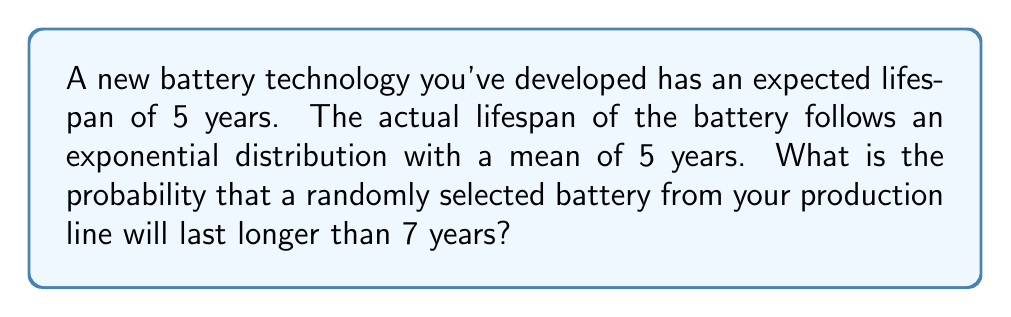Help me with this question. Let's approach this step-by-step:

1) The exponential distribution is often used to model the lifetime of electronic components. Its probability density function is given by:

   $$f(x) = \lambda e^{-\lambda x}$$

   where $\lambda$ is the rate parameter.

2) We're given that the mean of the distribution is 5 years. For an exponential distribution, the mean is equal to $\frac{1}{\lambda}$. So:

   $$\frac{1}{\lambda} = 5$$
   $$\lambda = \frac{1}{5} = 0.2$$

3) We want to find the probability that the battery lasts longer than 7 years. This is equivalent to finding the complement of the cumulative distribution function at x = 7:

   $$P(X > 7) = 1 - P(X \leq 7) = 1 - (1 - e^{-\lambda x})$$

4) Substituting our values:

   $$P(X > 7) = 1 - (1 - e^{-0.2 * 7})$$
   $$= e^{-0.2 * 7}$$
   $$= e^{-1.4}$$

5) Calculating this:

   $$e^{-1.4} \approx 0.2466$$

Therefore, the probability that a randomly selected battery will last longer than 7 years is approximately 0.2466 or 24.66%.
Answer: $0.2466$ or $24.66\%$ 